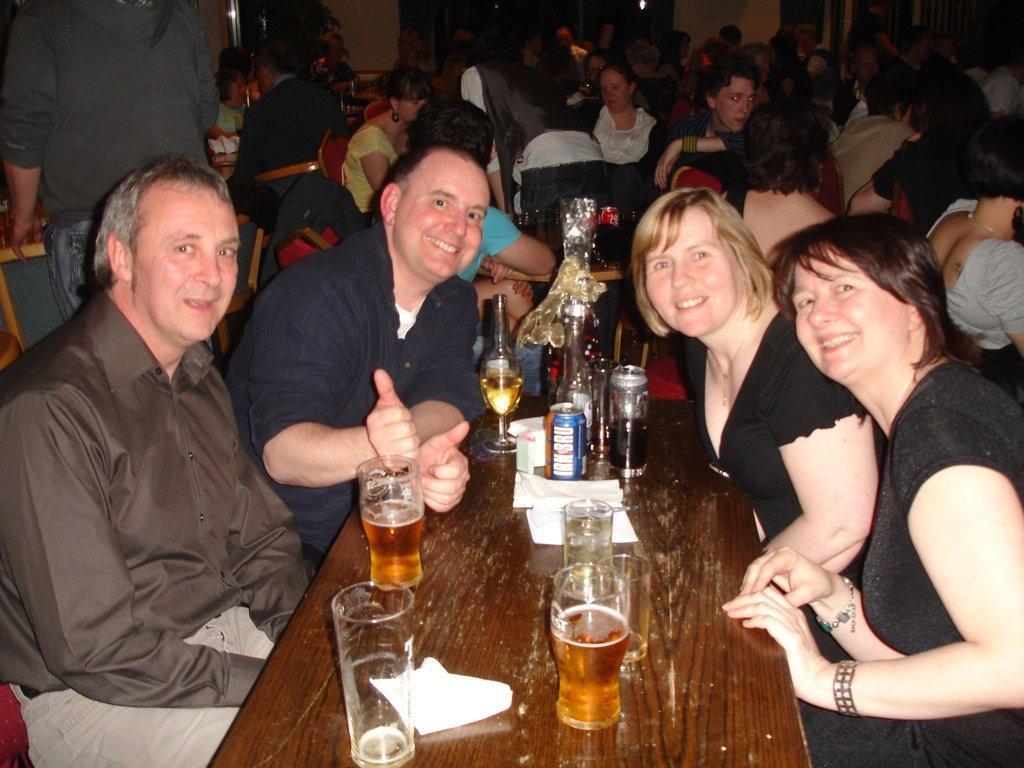Can you describe this image briefly? In this image there are group of persons sitting and having their drinks at the middle of the image there are glasses and bottles on top of the table. 